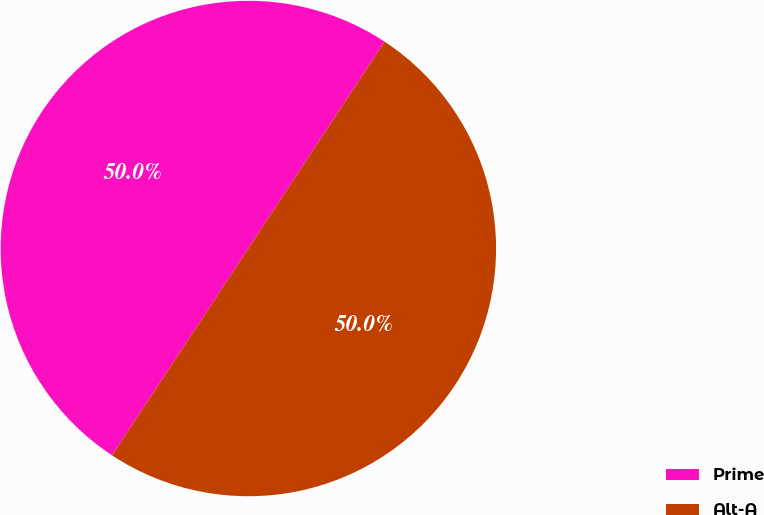Convert chart. <chart><loc_0><loc_0><loc_500><loc_500><pie_chart><fcel>Prime<fcel>Alt-A<nl><fcel>50.0%<fcel>50.0%<nl></chart> 